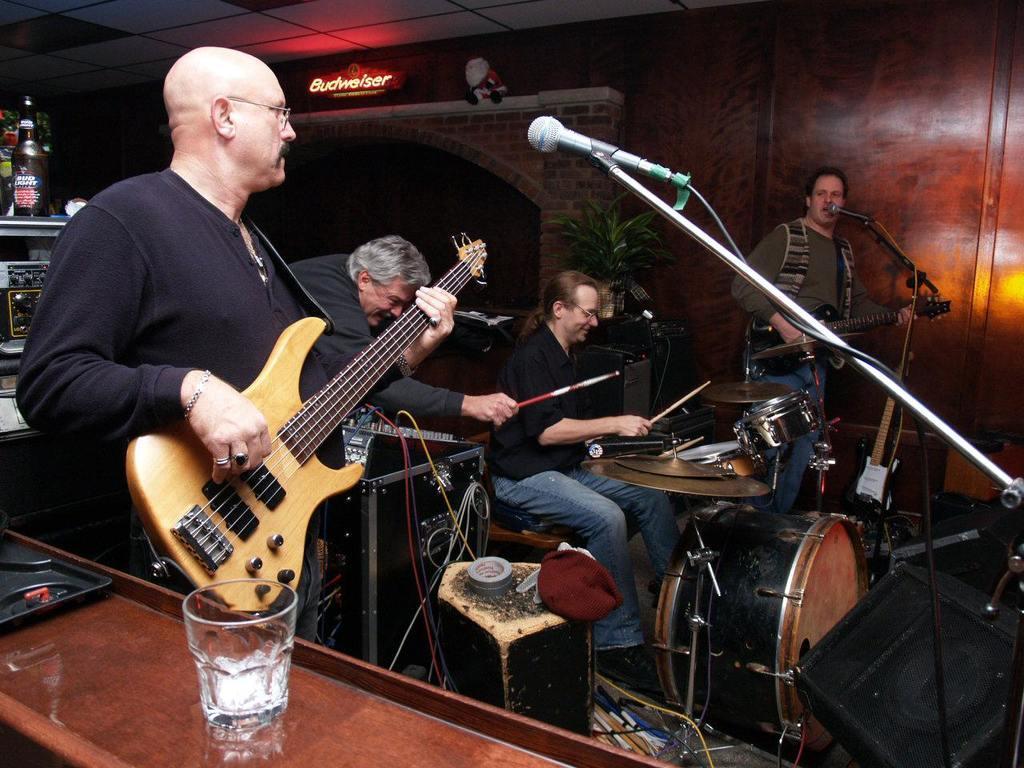In one or two sentences, can you explain what this image depicts? In the middle of the image there is a plant, Behind the plant there is a wall. At the top the image there is roof. Right side of the image a person playing guitar and singing. In the middle of the image there a person playing drum. Left side of the image there is a person playing guitar. Bottom left side of the image there is a table on the table there is a glass. Top left side of the image there is a bottle. 